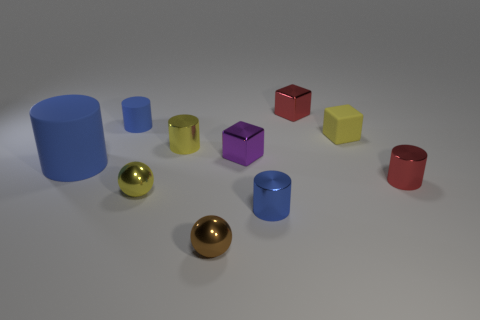Describe the lighting and shadows in this image. The image is lit with what appears to be a soft, diffused light source, casting gentle shadows that stretch away from the objects, contributing to the depth and three-dimensionality of the scene. The light seems to be coming from the upper left, as indicated by the direction of the shadows, creating a calm and evenly illuminated set-up. 